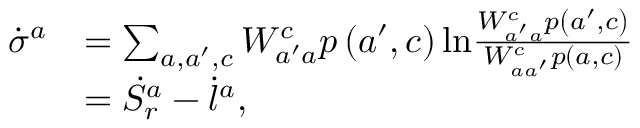<formula> <loc_0><loc_0><loc_500><loc_500>\begin{array} { r l } { \dot { \sigma } ^ { a } } & { = \sum _ { a , a ^ { \prime } , c } W _ { a ^ { \prime } a } ^ { c } p \left ( a ^ { \prime } , c \right ) \ln \frac { W _ { a ^ { \prime } a } ^ { c } p \left ( a ^ { \prime } , c \right ) } { W _ { a a ^ { \prime } } ^ { c } p \left ( a , c \right ) } } \\ & { = \dot { S } _ { r } ^ { a } - \dot { l } ^ { a } , } \end{array}</formula> 